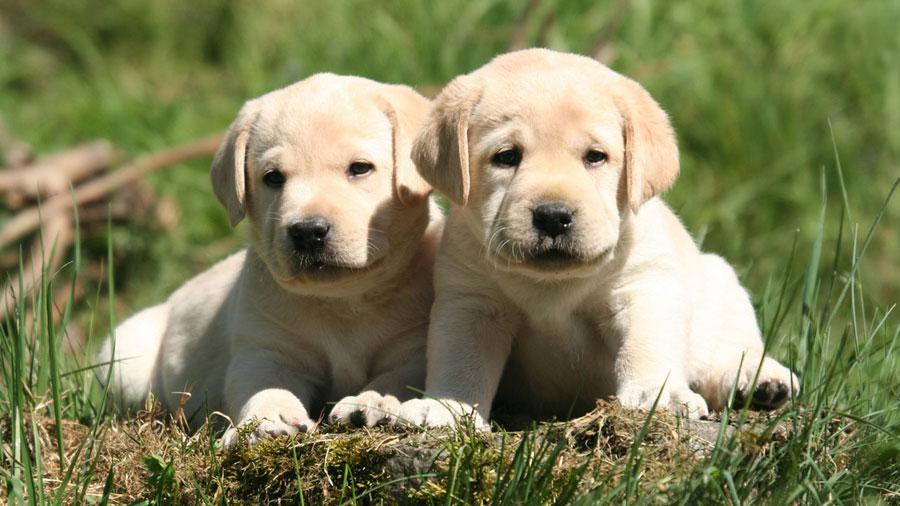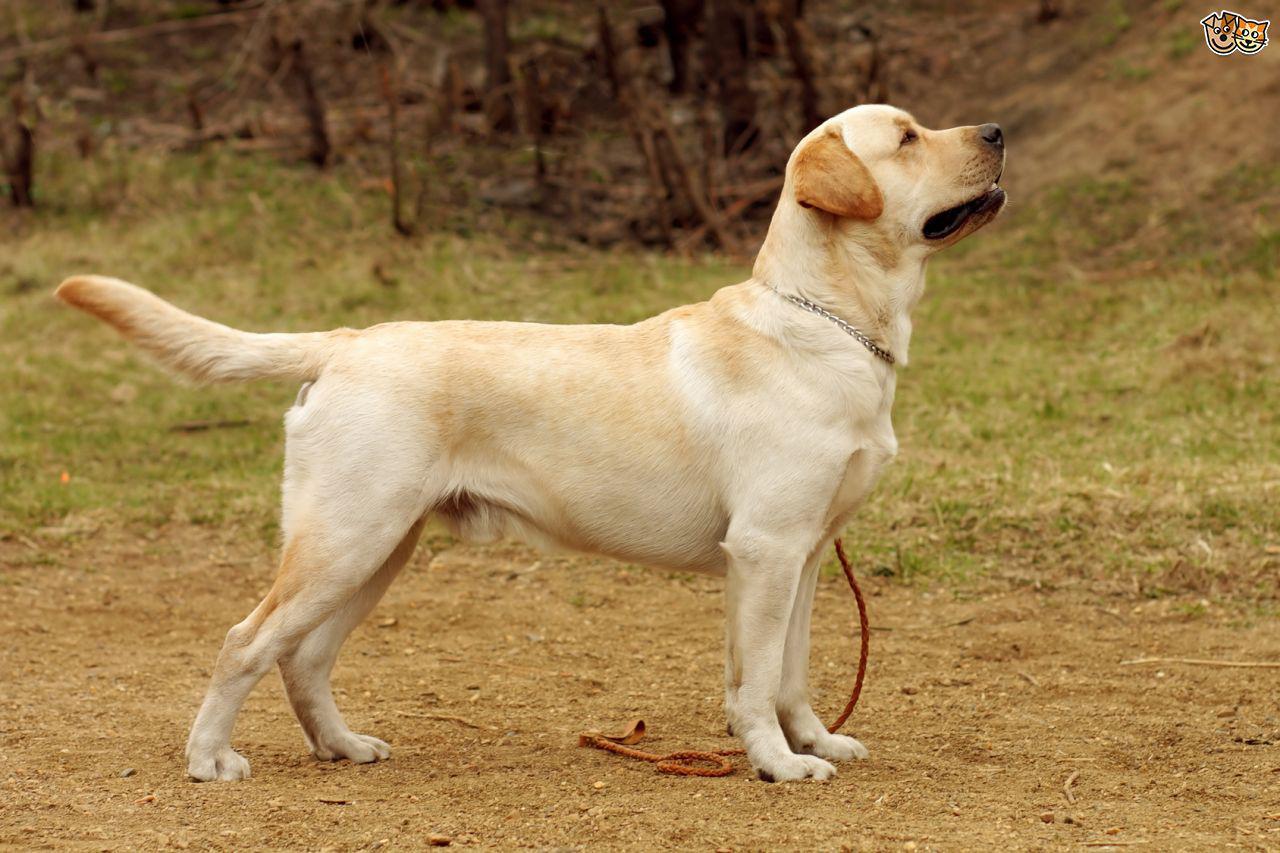The first image is the image on the left, the second image is the image on the right. Analyze the images presented: Is the assertion "In at least one image there are exactly two dogs outside together." valid? Answer yes or no. Yes. The first image is the image on the left, the second image is the image on the right. Given the left and right images, does the statement "There are two dogs in the left picture." hold true? Answer yes or no. Yes. 